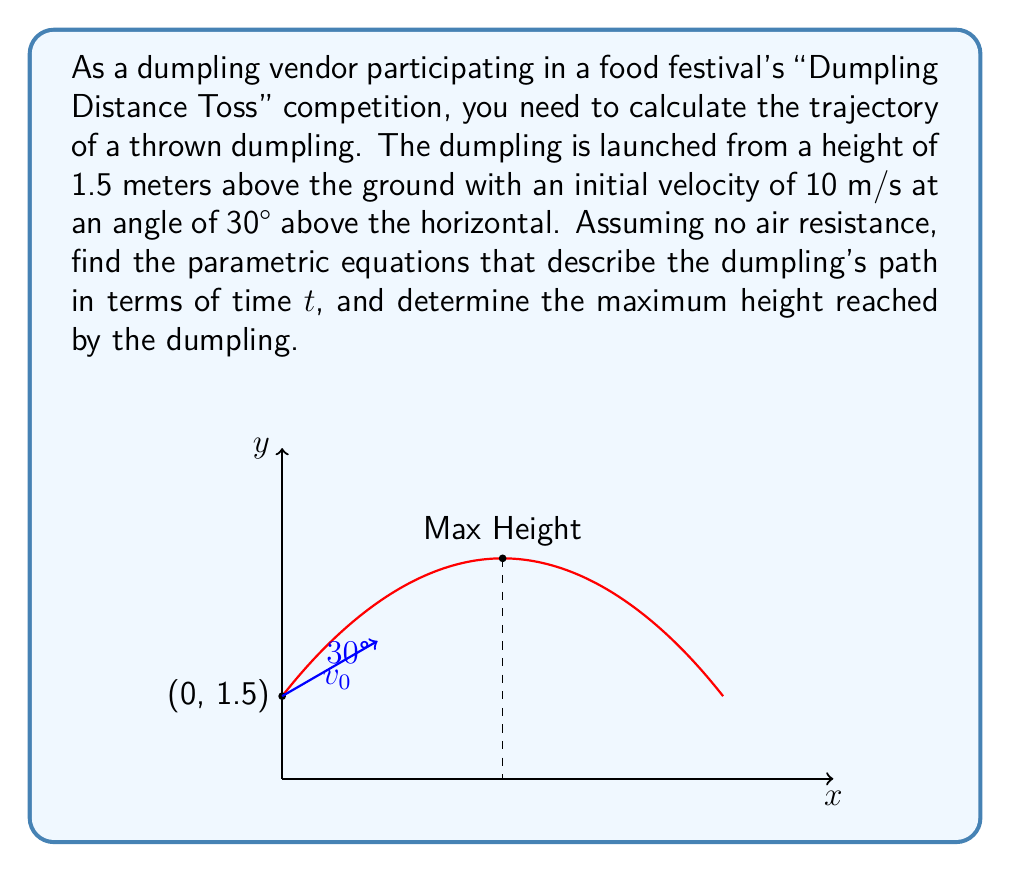Provide a solution to this math problem. Let's approach this step-by-step:

1) First, we need to define our variables:
   - Initial velocity: $v_0 = 10$ m/s
   - Angle of launch: $\theta = 30° = \frac{\pi}{6}$ radians
   - Initial height: $y_0 = 1.5$ m
   - Acceleration due to gravity: $g = 9.8$ m/s²

2) The parametric equations for projectile motion are:
   $$x(t) = v_0 \cos(\theta) t$$
   $$y(t) = y_0 + v_0 \sin(\theta) t - \frac{1}{2}gt^2$$

3) Substituting our values:
   $$x(t) = 10 \cos(\frac{\pi}{6}) t = 10 \cdot \frac{\sqrt{3}}{2} t \approx 8.66t$$
   $$y(t) = 1.5 + 10 \sin(\frac{\pi}{6}) t - \frac{1}{2} \cdot 9.8 t^2 = 1.5 + 5t - 4.9t^2$$

4) To find the maximum height, we need to find when the vertical velocity is zero:
   $$\frac{dy}{dt} = 5 - 9.8t = 0$$
   $$t = \frac{5}{9.8} \approx 0.51 \text{ seconds}$$

5) Substituting this time back into the equation for y(t):
   $$y_{max} = 1.5 + 5(0.51) - 4.9(0.51)^2 \approx 2.78 \text{ meters}$$
Answer: Parametric equations: $x(t) \approx 8.66t$, $y(t) = 1.5 + 5t - 4.9t^2$. Maximum height: 2.78 m. 